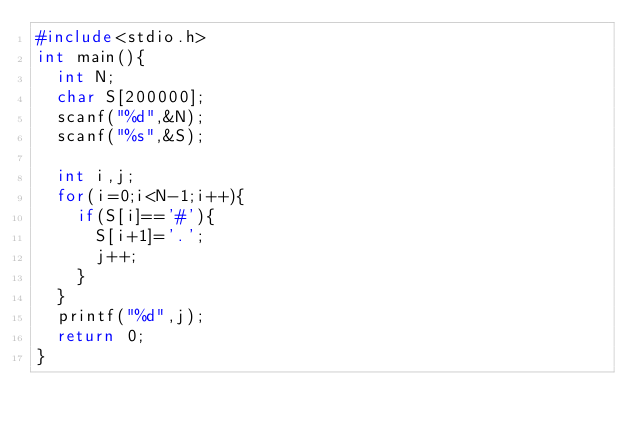Convert code to text. <code><loc_0><loc_0><loc_500><loc_500><_C_>#include<stdio.h>
int main(){
  int N;
  char S[200000];
  scanf("%d",&N);
  scanf("%s",&S);

  int i,j;
  for(i=0;i<N-1;i++){
    if(S[i]=='#'){
      S[i+1]='.';
      j++;
    }
  }
  printf("%d",j);
  return 0;
}
</code> 